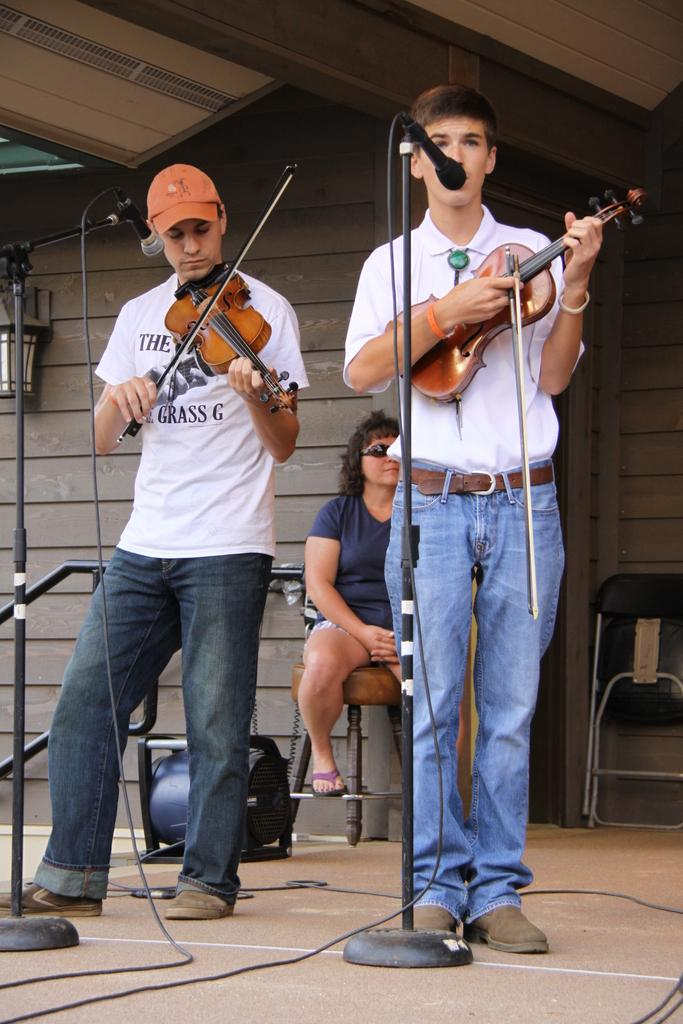How many people are in the image? There are two people in the image. What are the two people doing in the image? The two people are standing and playing violins. What is in front of the two people? There is a microphone in front of the two people. Can you describe the woman seated in the image? There is a woman seated on a chair behind the two people. What type of doll is sitting on the desk in the image? There is no doll or desk present in the image. 